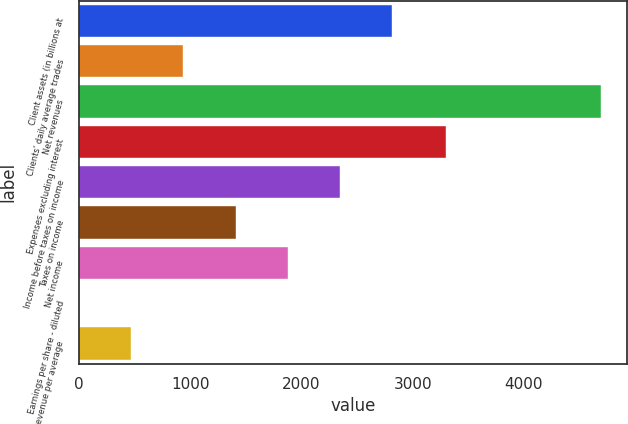<chart> <loc_0><loc_0><loc_500><loc_500><bar_chart><fcel>Client assets (in billions at<fcel>Clients' daily average trades<fcel>Net revenues<fcel>Expenses excluding interest<fcel>Income before taxes on income<fcel>Taxes on income<fcel>Net income<fcel>Earnings per share - diluted<fcel>Net revenue per average<nl><fcel>2814.88<fcel>938.76<fcel>4691<fcel>3299<fcel>2345.85<fcel>1407.79<fcel>1876.82<fcel>0.7<fcel>469.73<nl></chart> 